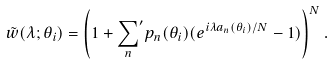Convert formula to latex. <formula><loc_0><loc_0><loc_500><loc_500>\tilde { w } ( \lambda ; \theta _ { i } ) = \left ( 1 + { \sum _ { n } } ^ { \prime } p _ { n } ( \theta _ { i } ) ( e ^ { i \lambda a _ { n } ( \theta _ { i } ) / N } - 1 ) \right ) ^ { N } .</formula> 